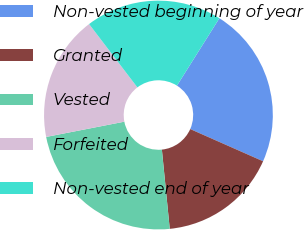Convert chart to OTSL. <chart><loc_0><loc_0><loc_500><loc_500><pie_chart><fcel>Non-vested beginning of year<fcel>Granted<fcel>Vested<fcel>Forfeited<fcel>Non-vested end of year<nl><fcel>22.68%<fcel>16.8%<fcel>23.51%<fcel>17.7%<fcel>19.31%<nl></chart> 